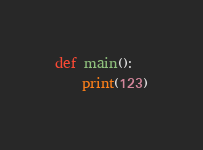Convert code to text. <code><loc_0><loc_0><loc_500><loc_500><_Python_>def main():
    print(123)
</code> 